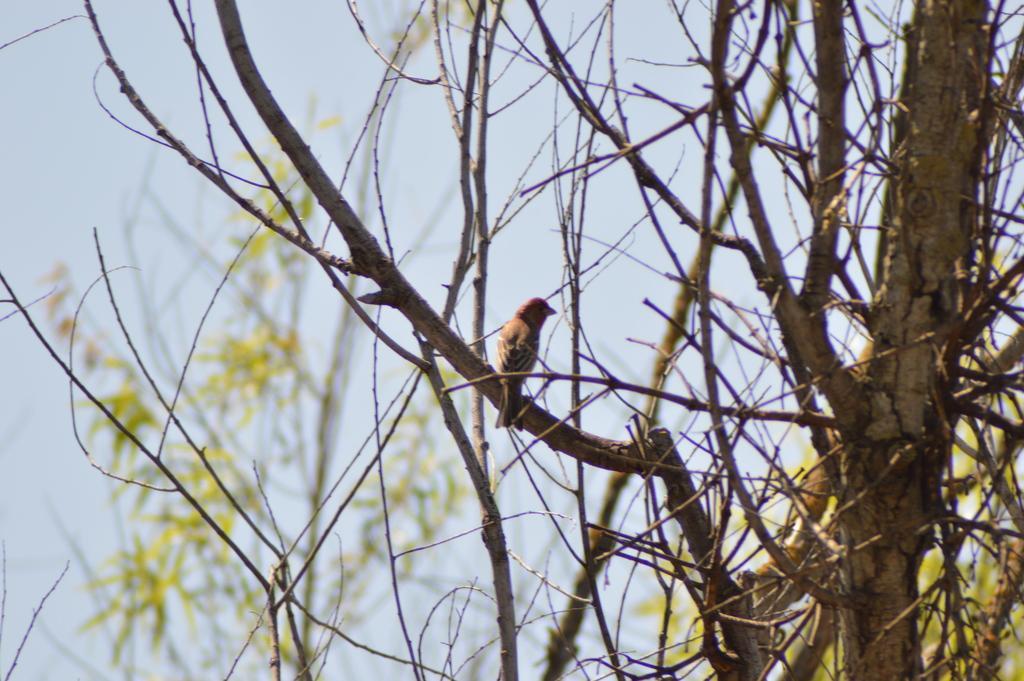Can you describe this image briefly? In this image there is a bird sitting on the tree stem. On the right side there is a tree with the stems. At the top there is sky. 